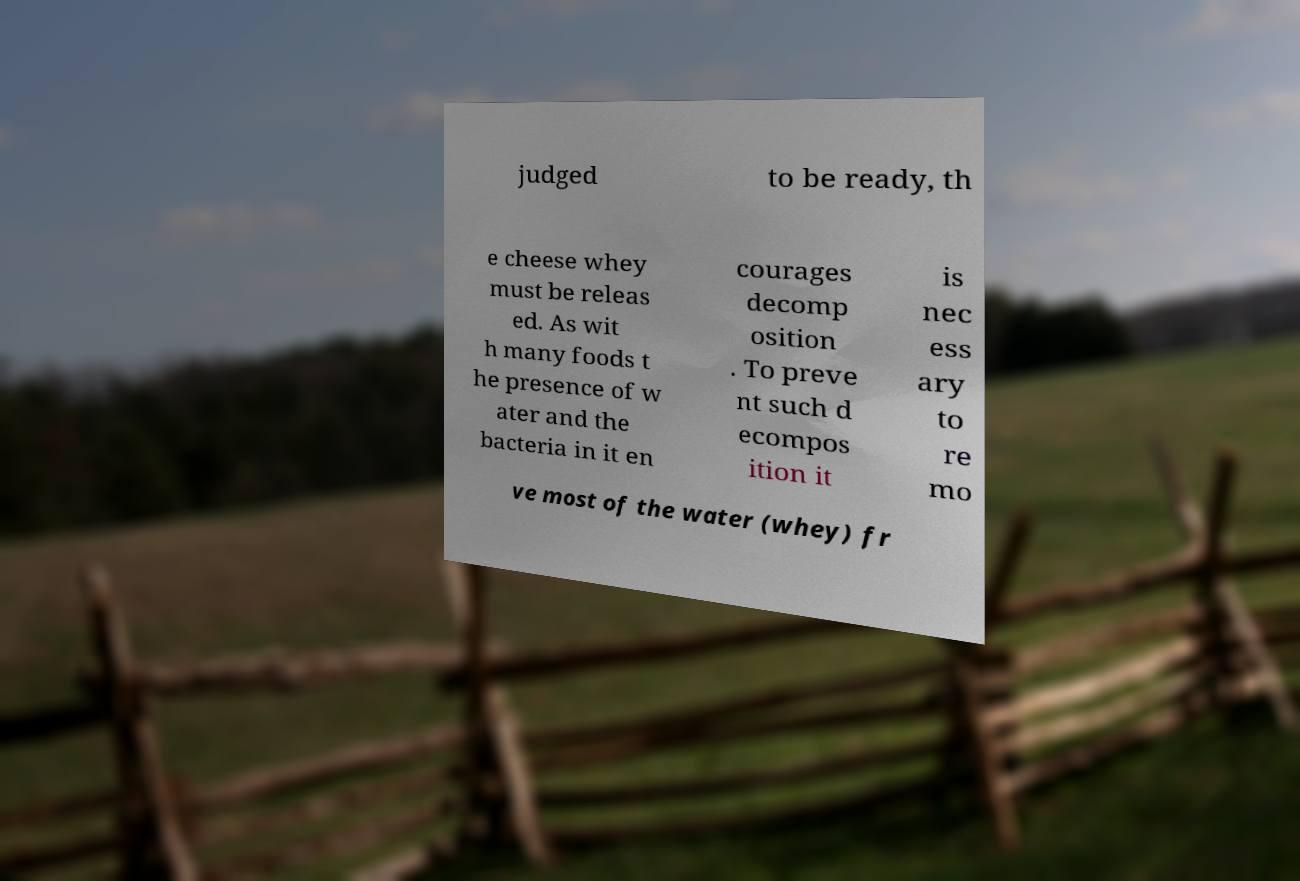Please identify and transcribe the text found in this image. judged to be ready, th e cheese whey must be releas ed. As wit h many foods t he presence of w ater and the bacteria in it en courages decomp osition . To preve nt such d ecompos ition it is nec ess ary to re mo ve most of the water (whey) fr 